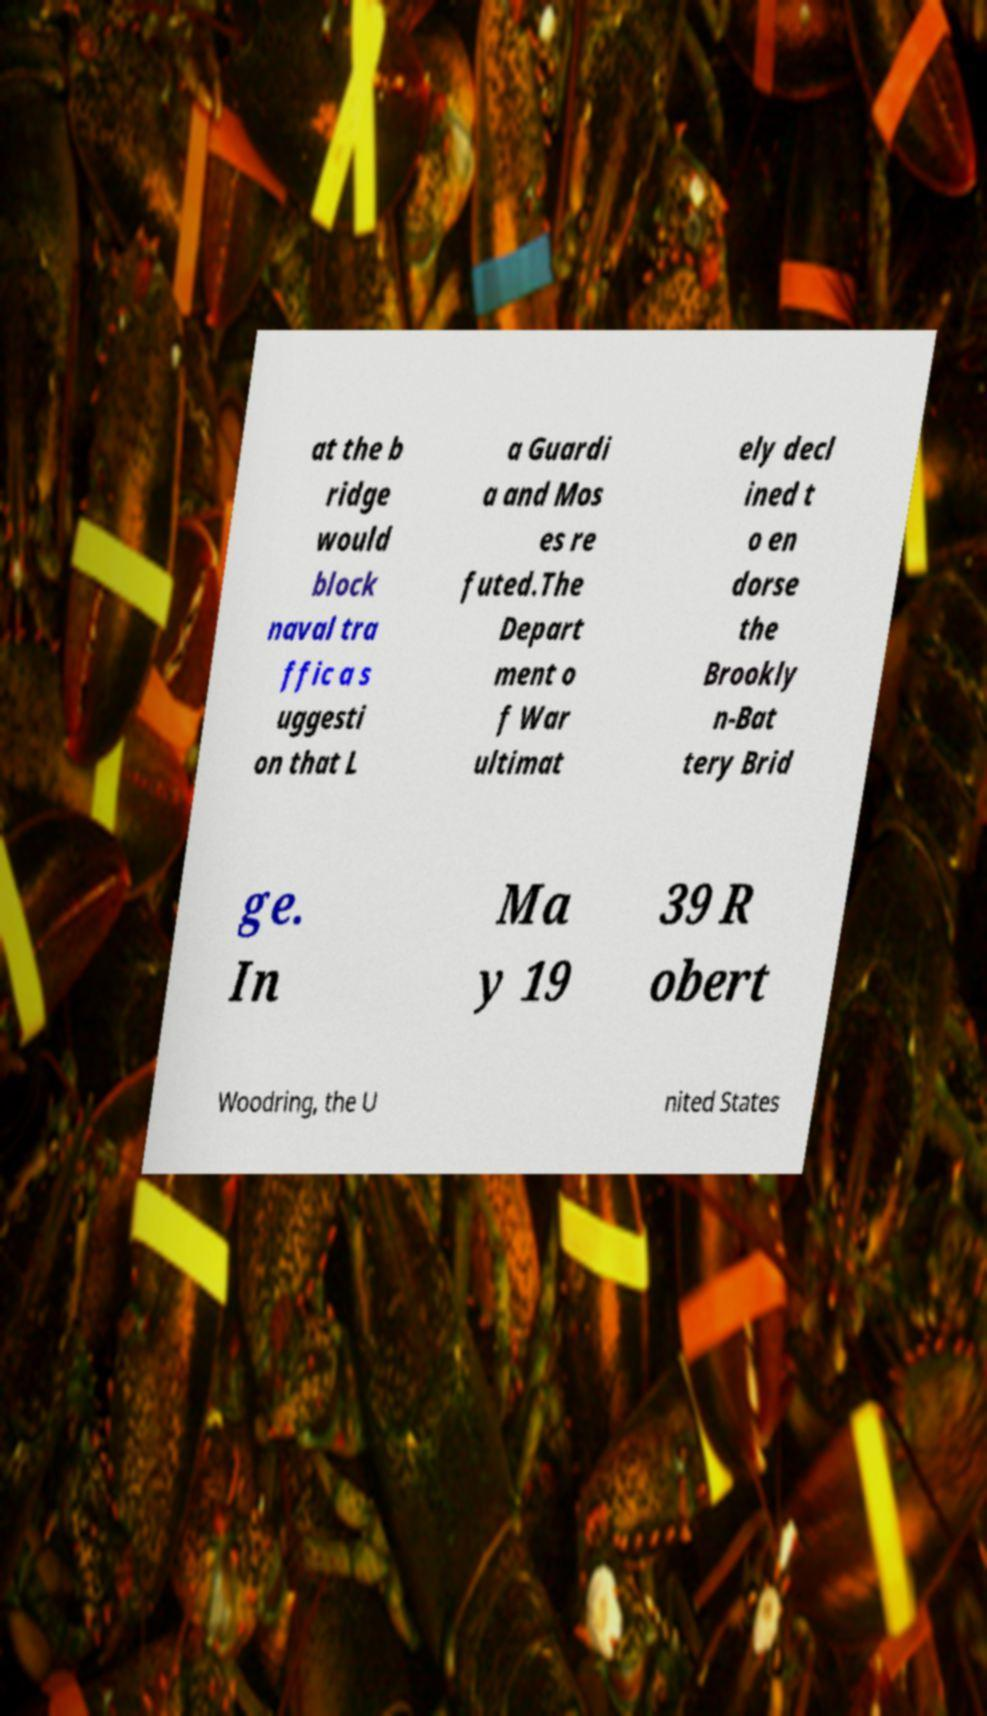What messages or text are displayed in this image? I need them in a readable, typed format. at the b ridge would block naval tra ffic a s uggesti on that L a Guardi a and Mos es re futed.The Depart ment o f War ultimat ely decl ined t o en dorse the Brookly n-Bat tery Brid ge. In Ma y 19 39 R obert Woodring, the U nited States 